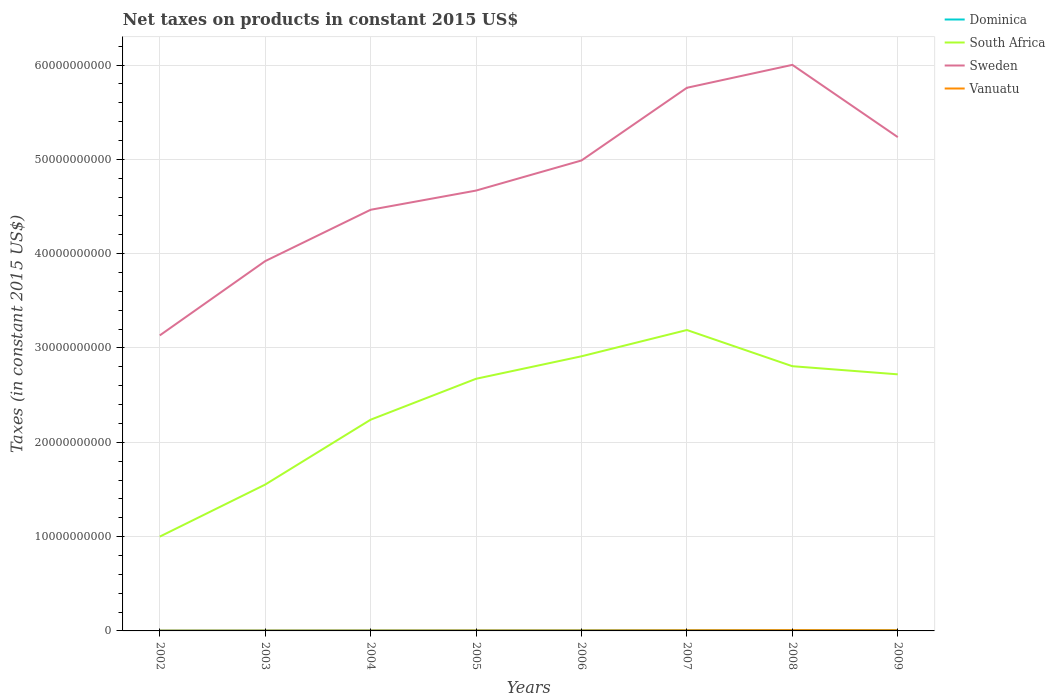How many different coloured lines are there?
Provide a short and direct response. 4. Is the number of lines equal to the number of legend labels?
Your response must be concise. Yes. Across all years, what is the maximum net taxes on products in South Africa?
Your response must be concise. 1.00e+1. What is the total net taxes on products in Vanuatu in the graph?
Offer a very short reply. -5.56e+06. What is the difference between the highest and the second highest net taxes on products in Dominica?
Offer a very short reply. 4.77e+07. How many years are there in the graph?
Provide a short and direct response. 8. What is the difference between two consecutive major ticks on the Y-axis?
Give a very brief answer. 1.00e+1. Are the values on the major ticks of Y-axis written in scientific E-notation?
Keep it short and to the point. No. Does the graph contain any zero values?
Offer a very short reply. No. Does the graph contain grids?
Provide a short and direct response. Yes. Where does the legend appear in the graph?
Keep it short and to the point. Top right. How many legend labels are there?
Provide a succinct answer. 4. How are the legend labels stacked?
Keep it short and to the point. Vertical. What is the title of the graph?
Ensure brevity in your answer.  Net taxes on products in constant 2015 US$. Does "United Kingdom" appear as one of the legend labels in the graph?
Ensure brevity in your answer.  No. What is the label or title of the X-axis?
Your answer should be very brief. Years. What is the label or title of the Y-axis?
Your answer should be compact. Taxes (in constant 2015 US$). What is the Taxes (in constant 2015 US$) in Dominica in 2002?
Keep it short and to the point. 3.84e+07. What is the Taxes (in constant 2015 US$) in South Africa in 2002?
Provide a succinct answer. 1.00e+1. What is the Taxes (in constant 2015 US$) in Sweden in 2002?
Give a very brief answer. 3.13e+1. What is the Taxes (in constant 2015 US$) in Vanuatu in 2002?
Give a very brief answer. 3.06e+07. What is the Taxes (in constant 2015 US$) in Dominica in 2003?
Keep it short and to the point. 4.41e+07. What is the Taxes (in constant 2015 US$) of South Africa in 2003?
Give a very brief answer. 1.55e+1. What is the Taxes (in constant 2015 US$) of Sweden in 2003?
Offer a very short reply. 3.92e+1. What is the Taxes (in constant 2015 US$) of Vanuatu in 2003?
Ensure brevity in your answer.  3.56e+07. What is the Taxes (in constant 2015 US$) of Dominica in 2004?
Your answer should be compact. 5.27e+07. What is the Taxes (in constant 2015 US$) in South Africa in 2004?
Your response must be concise. 2.24e+1. What is the Taxes (in constant 2015 US$) of Sweden in 2004?
Offer a very short reply. 4.47e+1. What is the Taxes (in constant 2015 US$) of Vanuatu in 2004?
Ensure brevity in your answer.  4.18e+07. What is the Taxes (in constant 2015 US$) in Dominica in 2005?
Offer a very short reply. 5.63e+07. What is the Taxes (in constant 2015 US$) in South Africa in 2005?
Provide a succinct answer. 2.67e+1. What is the Taxes (in constant 2015 US$) of Sweden in 2005?
Make the answer very short. 4.67e+1. What is the Taxes (in constant 2015 US$) of Vanuatu in 2005?
Offer a terse response. 4.74e+07. What is the Taxes (in constant 2015 US$) in Dominica in 2006?
Your answer should be very brief. 6.32e+07. What is the Taxes (in constant 2015 US$) in South Africa in 2006?
Your answer should be very brief. 2.91e+1. What is the Taxes (in constant 2015 US$) of Sweden in 2006?
Your answer should be very brief. 4.99e+1. What is the Taxes (in constant 2015 US$) of Vanuatu in 2006?
Keep it short and to the point. 5.19e+07. What is the Taxes (in constant 2015 US$) of Dominica in 2007?
Provide a succinct answer. 7.48e+07. What is the Taxes (in constant 2015 US$) of South Africa in 2007?
Your answer should be compact. 3.19e+1. What is the Taxes (in constant 2015 US$) in Sweden in 2007?
Provide a short and direct response. 5.76e+1. What is the Taxes (in constant 2015 US$) in Vanuatu in 2007?
Make the answer very short. 6.96e+07. What is the Taxes (in constant 2015 US$) of Dominica in 2008?
Provide a short and direct response. 8.21e+07. What is the Taxes (in constant 2015 US$) of South Africa in 2008?
Your response must be concise. 2.81e+1. What is the Taxes (in constant 2015 US$) in Sweden in 2008?
Keep it short and to the point. 6.00e+1. What is the Taxes (in constant 2015 US$) in Vanuatu in 2008?
Your answer should be very brief. 8.28e+07. What is the Taxes (in constant 2015 US$) in Dominica in 2009?
Give a very brief answer. 8.62e+07. What is the Taxes (in constant 2015 US$) of South Africa in 2009?
Your response must be concise. 2.72e+1. What is the Taxes (in constant 2015 US$) in Sweden in 2009?
Provide a succinct answer. 5.24e+1. What is the Taxes (in constant 2015 US$) of Vanuatu in 2009?
Provide a short and direct response. 7.68e+07. Across all years, what is the maximum Taxes (in constant 2015 US$) of Dominica?
Offer a terse response. 8.62e+07. Across all years, what is the maximum Taxes (in constant 2015 US$) in South Africa?
Provide a short and direct response. 3.19e+1. Across all years, what is the maximum Taxes (in constant 2015 US$) of Sweden?
Your answer should be compact. 6.00e+1. Across all years, what is the maximum Taxes (in constant 2015 US$) in Vanuatu?
Offer a terse response. 8.28e+07. Across all years, what is the minimum Taxes (in constant 2015 US$) in Dominica?
Offer a terse response. 3.84e+07. Across all years, what is the minimum Taxes (in constant 2015 US$) in South Africa?
Your answer should be very brief. 1.00e+1. Across all years, what is the minimum Taxes (in constant 2015 US$) of Sweden?
Ensure brevity in your answer.  3.13e+1. Across all years, what is the minimum Taxes (in constant 2015 US$) of Vanuatu?
Provide a short and direct response. 3.06e+07. What is the total Taxes (in constant 2015 US$) of Dominica in the graph?
Provide a succinct answer. 4.98e+08. What is the total Taxes (in constant 2015 US$) in South Africa in the graph?
Your answer should be very brief. 1.91e+11. What is the total Taxes (in constant 2015 US$) in Sweden in the graph?
Provide a short and direct response. 3.82e+11. What is the total Taxes (in constant 2015 US$) in Vanuatu in the graph?
Ensure brevity in your answer.  4.37e+08. What is the difference between the Taxes (in constant 2015 US$) in Dominica in 2002 and that in 2003?
Your response must be concise. -5.64e+06. What is the difference between the Taxes (in constant 2015 US$) of South Africa in 2002 and that in 2003?
Offer a very short reply. -5.52e+09. What is the difference between the Taxes (in constant 2015 US$) of Sweden in 2002 and that in 2003?
Your response must be concise. -7.88e+09. What is the difference between the Taxes (in constant 2015 US$) in Vanuatu in 2002 and that in 2003?
Offer a very short reply. -4.97e+06. What is the difference between the Taxes (in constant 2015 US$) in Dominica in 2002 and that in 2004?
Your answer should be very brief. -1.43e+07. What is the difference between the Taxes (in constant 2015 US$) of South Africa in 2002 and that in 2004?
Your answer should be compact. -1.24e+1. What is the difference between the Taxes (in constant 2015 US$) of Sweden in 2002 and that in 2004?
Keep it short and to the point. -1.33e+1. What is the difference between the Taxes (in constant 2015 US$) of Vanuatu in 2002 and that in 2004?
Keep it short and to the point. -1.12e+07. What is the difference between the Taxes (in constant 2015 US$) of Dominica in 2002 and that in 2005?
Ensure brevity in your answer.  -1.79e+07. What is the difference between the Taxes (in constant 2015 US$) in South Africa in 2002 and that in 2005?
Ensure brevity in your answer.  -1.67e+1. What is the difference between the Taxes (in constant 2015 US$) in Sweden in 2002 and that in 2005?
Ensure brevity in your answer.  -1.54e+1. What is the difference between the Taxes (in constant 2015 US$) of Vanuatu in 2002 and that in 2005?
Give a very brief answer. -1.68e+07. What is the difference between the Taxes (in constant 2015 US$) in Dominica in 2002 and that in 2006?
Provide a short and direct response. -2.48e+07. What is the difference between the Taxes (in constant 2015 US$) in South Africa in 2002 and that in 2006?
Ensure brevity in your answer.  -1.91e+1. What is the difference between the Taxes (in constant 2015 US$) in Sweden in 2002 and that in 2006?
Make the answer very short. -1.85e+1. What is the difference between the Taxes (in constant 2015 US$) of Vanuatu in 2002 and that in 2006?
Offer a very short reply. -2.13e+07. What is the difference between the Taxes (in constant 2015 US$) in Dominica in 2002 and that in 2007?
Ensure brevity in your answer.  -3.64e+07. What is the difference between the Taxes (in constant 2015 US$) in South Africa in 2002 and that in 2007?
Give a very brief answer. -2.19e+1. What is the difference between the Taxes (in constant 2015 US$) in Sweden in 2002 and that in 2007?
Offer a very short reply. -2.63e+1. What is the difference between the Taxes (in constant 2015 US$) of Vanuatu in 2002 and that in 2007?
Ensure brevity in your answer.  -3.90e+07. What is the difference between the Taxes (in constant 2015 US$) in Dominica in 2002 and that in 2008?
Keep it short and to the point. -4.36e+07. What is the difference between the Taxes (in constant 2015 US$) of South Africa in 2002 and that in 2008?
Ensure brevity in your answer.  -1.81e+1. What is the difference between the Taxes (in constant 2015 US$) in Sweden in 2002 and that in 2008?
Keep it short and to the point. -2.87e+1. What is the difference between the Taxes (in constant 2015 US$) of Vanuatu in 2002 and that in 2008?
Offer a terse response. -5.22e+07. What is the difference between the Taxes (in constant 2015 US$) of Dominica in 2002 and that in 2009?
Give a very brief answer. -4.77e+07. What is the difference between the Taxes (in constant 2015 US$) in South Africa in 2002 and that in 2009?
Make the answer very short. -1.72e+1. What is the difference between the Taxes (in constant 2015 US$) of Sweden in 2002 and that in 2009?
Keep it short and to the point. -2.10e+1. What is the difference between the Taxes (in constant 2015 US$) of Vanuatu in 2002 and that in 2009?
Make the answer very short. -4.61e+07. What is the difference between the Taxes (in constant 2015 US$) of Dominica in 2003 and that in 2004?
Offer a terse response. -8.61e+06. What is the difference between the Taxes (in constant 2015 US$) of South Africa in 2003 and that in 2004?
Provide a succinct answer. -6.88e+09. What is the difference between the Taxes (in constant 2015 US$) of Sweden in 2003 and that in 2004?
Your answer should be very brief. -5.44e+09. What is the difference between the Taxes (in constant 2015 US$) in Vanuatu in 2003 and that in 2004?
Keep it short and to the point. -6.23e+06. What is the difference between the Taxes (in constant 2015 US$) of Dominica in 2003 and that in 2005?
Your response must be concise. -1.22e+07. What is the difference between the Taxes (in constant 2015 US$) of South Africa in 2003 and that in 2005?
Give a very brief answer. -1.12e+1. What is the difference between the Taxes (in constant 2015 US$) in Sweden in 2003 and that in 2005?
Provide a succinct answer. -7.48e+09. What is the difference between the Taxes (in constant 2015 US$) in Vanuatu in 2003 and that in 2005?
Give a very brief answer. -1.18e+07. What is the difference between the Taxes (in constant 2015 US$) in Dominica in 2003 and that in 2006?
Ensure brevity in your answer.  -1.92e+07. What is the difference between the Taxes (in constant 2015 US$) in South Africa in 2003 and that in 2006?
Ensure brevity in your answer.  -1.36e+1. What is the difference between the Taxes (in constant 2015 US$) of Sweden in 2003 and that in 2006?
Provide a short and direct response. -1.07e+1. What is the difference between the Taxes (in constant 2015 US$) of Vanuatu in 2003 and that in 2006?
Ensure brevity in your answer.  -1.63e+07. What is the difference between the Taxes (in constant 2015 US$) of Dominica in 2003 and that in 2007?
Your answer should be very brief. -3.08e+07. What is the difference between the Taxes (in constant 2015 US$) of South Africa in 2003 and that in 2007?
Make the answer very short. -1.64e+1. What is the difference between the Taxes (in constant 2015 US$) in Sweden in 2003 and that in 2007?
Ensure brevity in your answer.  -1.84e+1. What is the difference between the Taxes (in constant 2015 US$) in Vanuatu in 2003 and that in 2007?
Ensure brevity in your answer.  -3.40e+07. What is the difference between the Taxes (in constant 2015 US$) of Dominica in 2003 and that in 2008?
Keep it short and to the point. -3.80e+07. What is the difference between the Taxes (in constant 2015 US$) in South Africa in 2003 and that in 2008?
Ensure brevity in your answer.  -1.25e+1. What is the difference between the Taxes (in constant 2015 US$) in Sweden in 2003 and that in 2008?
Provide a succinct answer. -2.08e+1. What is the difference between the Taxes (in constant 2015 US$) of Vanuatu in 2003 and that in 2008?
Give a very brief answer. -4.72e+07. What is the difference between the Taxes (in constant 2015 US$) of Dominica in 2003 and that in 2009?
Give a very brief answer. -4.21e+07. What is the difference between the Taxes (in constant 2015 US$) in South Africa in 2003 and that in 2009?
Offer a terse response. -1.17e+1. What is the difference between the Taxes (in constant 2015 US$) of Sweden in 2003 and that in 2009?
Give a very brief answer. -1.31e+1. What is the difference between the Taxes (in constant 2015 US$) in Vanuatu in 2003 and that in 2009?
Your answer should be compact. -4.12e+07. What is the difference between the Taxes (in constant 2015 US$) of Dominica in 2004 and that in 2005?
Provide a short and direct response. -3.61e+06. What is the difference between the Taxes (in constant 2015 US$) in South Africa in 2004 and that in 2005?
Your response must be concise. -4.34e+09. What is the difference between the Taxes (in constant 2015 US$) in Sweden in 2004 and that in 2005?
Ensure brevity in your answer.  -2.04e+09. What is the difference between the Taxes (in constant 2015 US$) in Vanuatu in 2004 and that in 2005?
Keep it short and to the point. -5.56e+06. What is the difference between the Taxes (in constant 2015 US$) of Dominica in 2004 and that in 2006?
Keep it short and to the point. -1.06e+07. What is the difference between the Taxes (in constant 2015 US$) of South Africa in 2004 and that in 2006?
Keep it short and to the point. -6.72e+09. What is the difference between the Taxes (in constant 2015 US$) of Sweden in 2004 and that in 2006?
Your answer should be very brief. -5.23e+09. What is the difference between the Taxes (in constant 2015 US$) in Vanuatu in 2004 and that in 2006?
Your answer should be very brief. -1.01e+07. What is the difference between the Taxes (in constant 2015 US$) in Dominica in 2004 and that in 2007?
Your response must be concise. -2.21e+07. What is the difference between the Taxes (in constant 2015 US$) in South Africa in 2004 and that in 2007?
Ensure brevity in your answer.  -9.51e+09. What is the difference between the Taxes (in constant 2015 US$) in Sweden in 2004 and that in 2007?
Your answer should be very brief. -1.29e+1. What is the difference between the Taxes (in constant 2015 US$) in Vanuatu in 2004 and that in 2007?
Make the answer very short. -2.78e+07. What is the difference between the Taxes (in constant 2015 US$) of Dominica in 2004 and that in 2008?
Offer a very short reply. -2.94e+07. What is the difference between the Taxes (in constant 2015 US$) in South Africa in 2004 and that in 2008?
Provide a short and direct response. -5.67e+09. What is the difference between the Taxes (in constant 2015 US$) of Sweden in 2004 and that in 2008?
Offer a very short reply. -1.54e+1. What is the difference between the Taxes (in constant 2015 US$) of Vanuatu in 2004 and that in 2008?
Provide a short and direct response. -4.10e+07. What is the difference between the Taxes (in constant 2015 US$) of Dominica in 2004 and that in 2009?
Your answer should be compact. -3.35e+07. What is the difference between the Taxes (in constant 2015 US$) in South Africa in 2004 and that in 2009?
Your answer should be compact. -4.81e+09. What is the difference between the Taxes (in constant 2015 US$) of Sweden in 2004 and that in 2009?
Provide a short and direct response. -7.70e+09. What is the difference between the Taxes (in constant 2015 US$) in Vanuatu in 2004 and that in 2009?
Provide a short and direct response. -3.49e+07. What is the difference between the Taxes (in constant 2015 US$) of Dominica in 2005 and that in 2006?
Give a very brief answer. -6.94e+06. What is the difference between the Taxes (in constant 2015 US$) of South Africa in 2005 and that in 2006?
Make the answer very short. -2.38e+09. What is the difference between the Taxes (in constant 2015 US$) in Sweden in 2005 and that in 2006?
Your answer should be compact. -3.19e+09. What is the difference between the Taxes (in constant 2015 US$) of Vanuatu in 2005 and that in 2006?
Provide a succinct answer. -4.52e+06. What is the difference between the Taxes (in constant 2015 US$) in Dominica in 2005 and that in 2007?
Give a very brief answer. -1.85e+07. What is the difference between the Taxes (in constant 2015 US$) in South Africa in 2005 and that in 2007?
Keep it short and to the point. -5.17e+09. What is the difference between the Taxes (in constant 2015 US$) in Sweden in 2005 and that in 2007?
Provide a short and direct response. -1.09e+1. What is the difference between the Taxes (in constant 2015 US$) in Vanuatu in 2005 and that in 2007?
Make the answer very short. -2.22e+07. What is the difference between the Taxes (in constant 2015 US$) in Dominica in 2005 and that in 2008?
Your answer should be compact. -2.58e+07. What is the difference between the Taxes (in constant 2015 US$) of South Africa in 2005 and that in 2008?
Make the answer very short. -1.33e+09. What is the difference between the Taxes (in constant 2015 US$) of Sweden in 2005 and that in 2008?
Offer a terse response. -1.33e+1. What is the difference between the Taxes (in constant 2015 US$) in Vanuatu in 2005 and that in 2008?
Offer a very short reply. -3.55e+07. What is the difference between the Taxes (in constant 2015 US$) in Dominica in 2005 and that in 2009?
Provide a short and direct response. -2.99e+07. What is the difference between the Taxes (in constant 2015 US$) in South Africa in 2005 and that in 2009?
Make the answer very short. -4.71e+08. What is the difference between the Taxes (in constant 2015 US$) of Sweden in 2005 and that in 2009?
Your answer should be compact. -5.67e+09. What is the difference between the Taxes (in constant 2015 US$) of Vanuatu in 2005 and that in 2009?
Your answer should be very brief. -2.94e+07. What is the difference between the Taxes (in constant 2015 US$) in Dominica in 2006 and that in 2007?
Make the answer very short. -1.16e+07. What is the difference between the Taxes (in constant 2015 US$) in South Africa in 2006 and that in 2007?
Make the answer very short. -2.79e+09. What is the difference between the Taxes (in constant 2015 US$) in Sweden in 2006 and that in 2007?
Your response must be concise. -7.71e+09. What is the difference between the Taxes (in constant 2015 US$) of Vanuatu in 2006 and that in 2007?
Ensure brevity in your answer.  -1.77e+07. What is the difference between the Taxes (in constant 2015 US$) of Dominica in 2006 and that in 2008?
Your response must be concise. -1.88e+07. What is the difference between the Taxes (in constant 2015 US$) in South Africa in 2006 and that in 2008?
Make the answer very short. 1.05e+09. What is the difference between the Taxes (in constant 2015 US$) in Sweden in 2006 and that in 2008?
Provide a succinct answer. -1.01e+1. What is the difference between the Taxes (in constant 2015 US$) in Vanuatu in 2006 and that in 2008?
Provide a succinct answer. -3.09e+07. What is the difference between the Taxes (in constant 2015 US$) of Dominica in 2006 and that in 2009?
Ensure brevity in your answer.  -2.29e+07. What is the difference between the Taxes (in constant 2015 US$) in South Africa in 2006 and that in 2009?
Provide a short and direct response. 1.91e+09. What is the difference between the Taxes (in constant 2015 US$) of Sweden in 2006 and that in 2009?
Keep it short and to the point. -2.47e+09. What is the difference between the Taxes (in constant 2015 US$) in Vanuatu in 2006 and that in 2009?
Your answer should be very brief. -2.49e+07. What is the difference between the Taxes (in constant 2015 US$) of Dominica in 2007 and that in 2008?
Keep it short and to the point. -7.23e+06. What is the difference between the Taxes (in constant 2015 US$) in South Africa in 2007 and that in 2008?
Your answer should be compact. 3.84e+09. What is the difference between the Taxes (in constant 2015 US$) in Sweden in 2007 and that in 2008?
Give a very brief answer. -2.43e+09. What is the difference between the Taxes (in constant 2015 US$) of Vanuatu in 2007 and that in 2008?
Offer a terse response. -1.32e+07. What is the difference between the Taxes (in constant 2015 US$) of Dominica in 2007 and that in 2009?
Your response must be concise. -1.13e+07. What is the difference between the Taxes (in constant 2015 US$) of South Africa in 2007 and that in 2009?
Ensure brevity in your answer.  4.70e+09. What is the difference between the Taxes (in constant 2015 US$) of Sweden in 2007 and that in 2009?
Provide a short and direct response. 5.23e+09. What is the difference between the Taxes (in constant 2015 US$) of Vanuatu in 2007 and that in 2009?
Offer a terse response. -7.15e+06. What is the difference between the Taxes (in constant 2015 US$) of Dominica in 2008 and that in 2009?
Keep it short and to the point. -4.10e+06. What is the difference between the Taxes (in constant 2015 US$) of South Africa in 2008 and that in 2009?
Provide a succinct answer. 8.62e+08. What is the difference between the Taxes (in constant 2015 US$) of Sweden in 2008 and that in 2009?
Make the answer very short. 7.66e+09. What is the difference between the Taxes (in constant 2015 US$) of Vanuatu in 2008 and that in 2009?
Provide a succinct answer. 6.08e+06. What is the difference between the Taxes (in constant 2015 US$) of Dominica in 2002 and the Taxes (in constant 2015 US$) of South Africa in 2003?
Your answer should be very brief. -1.55e+1. What is the difference between the Taxes (in constant 2015 US$) in Dominica in 2002 and the Taxes (in constant 2015 US$) in Sweden in 2003?
Your answer should be very brief. -3.92e+1. What is the difference between the Taxes (in constant 2015 US$) in Dominica in 2002 and the Taxes (in constant 2015 US$) in Vanuatu in 2003?
Give a very brief answer. 2.84e+06. What is the difference between the Taxes (in constant 2015 US$) in South Africa in 2002 and the Taxes (in constant 2015 US$) in Sweden in 2003?
Provide a short and direct response. -2.92e+1. What is the difference between the Taxes (in constant 2015 US$) of South Africa in 2002 and the Taxes (in constant 2015 US$) of Vanuatu in 2003?
Provide a short and direct response. 9.96e+09. What is the difference between the Taxes (in constant 2015 US$) of Sweden in 2002 and the Taxes (in constant 2015 US$) of Vanuatu in 2003?
Your response must be concise. 3.13e+1. What is the difference between the Taxes (in constant 2015 US$) in Dominica in 2002 and the Taxes (in constant 2015 US$) in South Africa in 2004?
Your answer should be very brief. -2.24e+1. What is the difference between the Taxes (in constant 2015 US$) of Dominica in 2002 and the Taxes (in constant 2015 US$) of Sweden in 2004?
Provide a short and direct response. -4.46e+1. What is the difference between the Taxes (in constant 2015 US$) of Dominica in 2002 and the Taxes (in constant 2015 US$) of Vanuatu in 2004?
Offer a very short reply. -3.39e+06. What is the difference between the Taxes (in constant 2015 US$) in South Africa in 2002 and the Taxes (in constant 2015 US$) in Sweden in 2004?
Provide a short and direct response. -3.47e+1. What is the difference between the Taxes (in constant 2015 US$) of South Africa in 2002 and the Taxes (in constant 2015 US$) of Vanuatu in 2004?
Your answer should be compact. 9.96e+09. What is the difference between the Taxes (in constant 2015 US$) of Sweden in 2002 and the Taxes (in constant 2015 US$) of Vanuatu in 2004?
Provide a succinct answer. 3.13e+1. What is the difference between the Taxes (in constant 2015 US$) in Dominica in 2002 and the Taxes (in constant 2015 US$) in South Africa in 2005?
Ensure brevity in your answer.  -2.67e+1. What is the difference between the Taxes (in constant 2015 US$) in Dominica in 2002 and the Taxes (in constant 2015 US$) in Sweden in 2005?
Your answer should be compact. -4.67e+1. What is the difference between the Taxes (in constant 2015 US$) of Dominica in 2002 and the Taxes (in constant 2015 US$) of Vanuatu in 2005?
Offer a terse response. -8.95e+06. What is the difference between the Taxes (in constant 2015 US$) of South Africa in 2002 and the Taxes (in constant 2015 US$) of Sweden in 2005?
Offer a terse response. -3.67e+1. What is the difference between the Taxes (in constant 2015 US$) of South Africa in 2002 and the Taxes (in constant 2015 US$) of Vanuatu in 2005?
Your response must be concise. 9.95e+09. What is the difference between the Taxes (in constant 2015 US$) of Sweden in 2002 and the Taxes (in constant 2015 US$) of Vanuatu in 2005?
Make the answer very short. 3.13e+1. What is the difference between the Taxes (in constant 2015 US$) of Dominica in 2002 and the Taxes (in constant 2015 US$) of South Africa in 2006?
Keep it short and to the point. -2.91e+1. What is the difference between the Taxes (in constant 2015 US$) of Dominica in 2002 and the Taxes (in constant 2015 US$) of Sweden in 2006?
Provide a short and direct response. -4.98e+1. What is the difference between the Taxes (in constant 2015 US$) in Dominica in 2002 and the Taxes (in constant 2015 US$) in Vanuatu in 2006?
Offer a very short reply. -1.35e+07. What is the difference between the Taxes (in constant 2015 US$) of South Africa in 2002 and the Taxes (in constant 2015 US$) of Sweden in 2006?
Give a very brief answer. -3.99e+1. What is the difference between the Taxes (in constant 2015 US$) of South Africa in 2002 and the Taxes (in constant 2015 US$) of Vanuatu in 2006?
Give a very brief answer. 9.95e+09. What is the difference between the Taxes (in constant 2015 US$) in Sweden in 2002 and the Taxes (in constant 2015 US$) in Vanuatu in 2006?
Provide a short and direct response. 3.13e+1. What is the difference between the Taxes (in constant 2015 US$) in Dominica in 2002 and the Taxes (in constant 2015 US$) in South Africa in 2007?
Your answer should be compact. -3.19e+1. What is the difference between the Taxes (in constant 2015 US$) of Dominica in 2002 and the Taxes (in constant 2015 US$) of Sweden in 2007?
Offer a very short reply. -5.76e+1. What is the difference between the Taxes (in constant 2015 US$) in Dominica in 2002 and the Taxes (in constant 2015 US$) in Vanuatu in 2007?
Make the answer very short. -3.12e+07. What is the difference between the Taxes (in constant 2015 US$) of South Africa in 2002 and the Taxes (in constant 2015 US$) of Sweden in 2007?
Your response must be concise. -4.76e+1. What is the difference between the Taxes (in constant 2015 US$) in South Africa in 2002 and the Taxes (in constant 2015 US$) in Vanuatu in 2007?
Keep it short and to the point. 9.93e+09. What is the difference between the Taxes (in constant 2015 US$) of Sweden in 2002 and the Taxes (in constant 2015 US$) of Vanuatu in 2007?
Your answer should be very brief. 3.13e+1. What is the difference between the Taxes (in constant 2015 US$) in Dominica in 2002 and the Taxes (in constant 2015 US$) in South Africa in 2008?
Your answer should be compact. -2.80e+1. What is the difference between the Taxes (in constant 2015 US$) in Dominica in 2002 and the Taxes (in constant 2015 US$) in Sweden in 2008?
Offer a very short reply. -6.00e+1. What is the difference between the Taxes (in constant 2015 US$) in Dominica in 2002 and the Taxes (in constant 2015 US$) in Vanuatu in 2008?
Make the answer very short. -4.44e+07. What is the difference between the Taxes (in constant 2015 US$) of South Africa in 2002 and the Taxes (in constant 2015 US$) of Sweden in 2008?
Give a very brief answer. -5.00e+1. What is the difference between the Taxes (in constant 2015 US$) of South Africa in 2002 and the Taxes (in constant 2015 US$) of Vanuatu in 2008?
Your answer should be very brief. 9.92e+09. What is the difference between the Taxes (in constant 2015 US$) in Sweden in 2002 and the Taxes (in constant 2015 US$) in Vanuatu in 2008?
Keep it short and to the point. 3.12e+1. What is the difference between the Taxes (in constant 2015 US$) in Dominica in 2002 and the Taxes (in constant 2015 US$) in South Africa in 2009?
Offer a very short reply. -2.72e+1. What is the difference between the Taxes (in constant 2015 US$) of Dominica in 2002 and the Taxes (in constant 2015 US$) of Sweden in 2009?
Your response must be concise. -5.23e+1. What is the difference between the Taxes (in constant 2015 US$) in Dominica in 2002 and the Taxes (in constant 2015 US$) in Vanuatu in 2009?
Ensure brevity in your answer.  -3.83e+07. What is the difference between the Taxes (in constant 2015 US$) of South Africa in 2002 and the Taxes (in constant 2015 US$) of Sweden in 2009?
Offer a terse response. -4.24e+1. What is the difference between the Taxes (in constant 2015 US$) of South Africa in 2002 and the Taxes (in constant 2015 US$) of Vanuatu in 2009?
Keep it short and to the point. 9.92e+09. What is the difference between the Taxes (in constant 2015 US$) of Sweden in 2002 and the Taxes (in constant 2015 US$) of Vanuatu in 2009?
Give a very brief answer. 3.13e+1. What is the difference between the Taxes (in constant 2015 US$) of Dominica in 2003 and the Taxes (in constant 2015 US$) of South Africa in 2004?
Offer a terse response. -2.24e+1. What is the difference between the Taxes (in constant 2015 US$) in Dominica in 2003 and the Taxes (in constant 2015 US$) in Sweden in 2004?
Give a very brief answer. -4.46e+1. What is the difference between the Taxes (in constant 2015 US$) of Dominica in 2003 and the Taxes (in constant 2015 US$) of Vanuatu in 2004?
Offer a terse response. 2.26e+06. What is the difference between the Taxes (in constant 2015 US$) of South Africa in 2003 and the Taxes (in constant 2015 US$) of Sweden in 2004?
Your answer should be compact. -2.91e+1. What is the difference between the Taxes (in constant 2015 US$) in South Africa in 2003 and the Taxes (in constant 2015 US$) in Vanuatu in 2004?
Your answer should be compact. 1.55e+1. What is the difference between the Taxes (in constant 2015 US$) of Sweden in 2003 and the Taxes (in constant 2015 US$) of Vanuatu in 2004?
Make the answer very short. 3.92e+1. What is the difference between the Taxes (in constant 2015 US$) of Dominica in 2003 and the Taxes (in constant 2015 US$) of South Africa in 2005?
Give a very brief answer. -2.67e+1. What is the difference between the Taxes (in constant 2015 US$) of Dominica in 2003 and the Taxes (in constant 2015 US$) of Sweden in 2005?
Your answer should be compact. -4.66e+1. What is the difference between the Taxes (in constant 2015 US$) of Dominica in 2003 and the Taxes (in constant 2015 US$) of Vanuatu in 2005?
Offer a terse response. -3.30e+06. What is the difference between the Taxes (in constant 2015 US$) in South Africa in 2003 and the Taxes (in constant 2015 US$) in Sweden in 2005?
Ensure brevity in your answer.  -3.12e+1. What is the difference between the Taxes (in constant 2015 US$) of South Africa in 2003 and the Taxes (in constant 2015 US$) of Vanuatu in 2005?
Provide a short and direct response. 1.55e+1. What is the difference between the Taxes (in constant 2015 US$) in Sweden in 2003 and the Taxes (in constant 2015 US$) in Vanuatu in 2005?
Give a very brief answer. 3.92e+1. What is the difference between the Taxes (in constant 2015 US$) in Dominica in 2003 and the Taxes (in constant 2015 US$) in South Africa in 2006?
Your answer should be very brief. -2.91e+1. What is the difference between the Taxes (in constant 2015 US$) in Dominica in 2003 and the Taxes (in constant 2015 US$) in Sweden in 2006?
Make the answer very short. -4.98e+1. What is the difference between the Taxes (in constant 2015 US$) of Dominica in 2003 and the Taxes (in constant 2015 US$) of Vanuatu in 2006?
Your answer should be very brief. -7.82e+06. What is the difference between the Taxes (in constant 2015 US$) in South Africa in 2003 and the Taxes (in constant 2015 US$) in Sweden in 2006?
Your response must be concise. -3.44e+1. What is the difference between the Taxes (in constant 2015 US$) of South Africa in 2003 and the Taxes (in constant 2015 US$) of Vanuatu in 2006?
Offer a very short reply. 1.55e+1. What is the difference between the Taxes (in constant 2015 US$) in Sweden in 2003 and the Taxes (in constant 2015 US$) in Vanuatu in 2006?
Give a very brief answer. 3.92e+1. What is the difference between the Taxes (in constant 2015 US$) in Dominica in 2003 and the Taxes (in constant 2015 US$) in South Africa in 2007?
Ensure brevity in your answer.  -3.19e+1. What is the difference between the Taxes (in constant 2015 US$) of Dominica in 2003 and the Taxes (in constant 2015 US$) of Sweden in 2007?
Your answer should be compact. -5.75e+1. What is the difference between the Taxes (in constant 2015 US$) in Dominica in 2003 and the Taxes (in constant 2015 US$) in Vanuatu in 2007?
Offer a terse response. -2.55e+07. What is the difference between the Taxes (in constant 2015 US$) in South Africa in 2003 and the Taxes (in constant 2015 US$) in Sweden in 2007?
Provide a succinct answer. -4.21e+1. What is the difference between the Taxes (in constant 2015 US$) of South Africa in 2003 and the Taxes (in constant 2015 US$) of Vanuatu in 2007?
Offer a terse response. 1.54e+1. What is the difference between the Taxes (in constant 2015 US$) of Sweden in 2003 and the Taxes (in constant 2015 US$) of Vanuatu in 2007?
Your answer should be very brief. 3.91e+1. What is the difference between the Taxes (in constant 2015 US$) in Dominica in 2003 and the Taxes (in constant 2015 US$) in South Africa in 2008?
Keep it short and to the point. -2.80e+1. What is the difference between the Taxes (in constant 2015 US$) of Dominica in 2003 and the Taxes (in constant 2015 US$) of Sweden in 2008?
Your response must be concise. -6.00e+1. What is the difference between the Taxes (in constant 2015 US$) in Dominica in 2003 and the Taxes (in constant 2015 US$) in Vanuatu in 2008?
Offer a very short reply. -3.88e+07. What is the difference between the Taxes (in constant 2015 US$) in South Africa in 2003 and the Taxes (in constant 2015 US$) in Sweden in 2008?
Your response must be concise. -4.45e+1. What is the difference between the Taxes (in constant 2015 US$) of South Africa in 2003 and the Taxes (in constant 2015 US$) of Vanuatu in 2008?
Provide a succinct answer. 1.54e+1. What is the difference between the Taxes (in constant 2015 US$) of Sweden in 2003 and the Taxes (in constant 2015 US$) of Vanuatu in 2008?
Make the answer very short. 3.91e+1. What is the difference between the Taxes (in constant 2015 US$) of Dominica in 2003 and the Taxes (in constant 2015 US$) of South Africa in 2009?
Make the answer very short. -2.72e+1. What is the difference between the Taxes (in constant 2015 US$) of Dominica in 2003 and the Taxes (in constant 2015 US$) of Sweden in 2009?
Keep it short and to the point. -5.23e+1. What is the difference between the Taxes (in constant 2015 US$) of Dominica in 2003 and the Taxes (in constant 2015 US$) of Vanuatu in 2009?
Your response must be concise. -3.27e+07. What is the difference between the Taxes (in constant 2015 US$) of South Africa in 2003 and the Taxes (in constant 2015 US$) of Sweden in 2009?
Your answer should be compact. -3.68e+1. What is the difference between the Taxes (in constant 2015 US$) of South Africa in 2003 and the Taxes (in constant 2015 US$) of Vanuatu in 2009?
Ensure brevity in your answer.  1.54e+1. What is the difference between the Taxes (in constant 2015 US$) in Sweden in 2003 and the Taxes (in constant 2015 US$) in Vanuatu in 2009?
Your response must be concise. 3.91e+1. What is the difference between the Taxes (in constant 2015 US$) in Dominica in 2004 and the Taxes (in constant 2015 US$) in South Africa in 2005?
Give a very brief answer. -2.67e+1. What is the difference between the Taxes (in constant 2015 US$) of Dominica in 2004 and the Taxes (in constant 2015 US$) of Sweden in 2005?
Ensure brevity in your answer.  -4.66e+1. What is the difference between the Taxes (in constant 2015 US$) in Dominica in 2004 and the Taxes (in constant 2015 US$) in Vanuatu in 2005?
Give a very brief answer. 5.31e+06. What is the difference between the Taxes (in constant 2015 US$) of South Africa in 2004 and the Taxes (in constant 2015 US$) of Sweden in 2005?
Make the answer very short. -2.43e+1. What is the difference between the Taxes (in constant 2015 US$) of South Africa in 2004 and the Taxes (in constant 2015 US$) of Vanuatu in 2005?
Give a very brief answer. 2.23e+1. What is the difference between the Taxes (in constant 2015 US$) in Sweden in 2004 and the Taxes (in constant 2015 US$) in Vanuatu in 2005?
Your answer should be very brief. 4.46e+1. What is the difference between the Taxes (in constant 2015 US$) of Dominica in 2004 and the Taxes (in constant 2015 US$) of South Africa in 2006?
Make the answer very short. -2.91e+1. What is the difference between the Taxes (in constant 2015 US$) of Dominica in 2004 and the Taxes (in constant 2015 US$) of Sweden in 2006?
Ensure brevity in your answer.  -4.98e+1. What is the difference between the Taxes (in constant 2015 US$) in Dominica in 2004 and the Taxes (in constant 2015 US$) in Vanuatu in 2006?
Make the answer very short. 7.89e+05. What is the difference between the Taxes (in constant 2015 US$) of South Africa in 2004 and the Taxes (in constant 2015 US$) of Sweden in 2006?
Give a very brief answer. -2.75e+1. What is the difference between the Taxes (in constant 2015 US$) in South Africa in 2004 and the Taxes (in constant 2015 US$) in Vanuatu in 2006?
Keep it short and to the point. 2.23e+1. What is the difference between the Taxes (in constant 2015 US$) in Sweden in 2004 and the Taxes (in constant 2015 US$) in Vanuatu in 2006?
Offer a very short reply. 4.46e+1. What is the difference between the Taxes (in constant 2015 US$) of Dominica in 2004 and the Taxes (in constant 2015 US$) of South Africa in 2007?
Provide a succinct answer. -3.19e+1. What is the difference between the Taxes (in constant 2015 US$) of Dominica in 2004 and the Taxes (in constant 2015 US$) of Sweden in 2007?
Your answer should be compact. -5.75e+1. What is the difference between the Taxes (in constant 2015 US$) of Dominica in 2004 and the Taxes (in constant 2015 US$) of Vanuatu in 2007?
Give a very brief answer. -1.69e+07. What is the difference between the Taxes (in constant 2015 US$) in South Africa in 2004 and the Taxes (in constant 2015 US$) in Sweden in 2007?
Give a very brief answer. -3.52e+1. What is the difference between the Taxes (in constant 2015 US$) of South Africa in 2004 and the Taxes (in constant 2015 US$) of Vanuatu in 2007?
Give a very brief answer. 2.23e+1. What is the difference between the Taxes (in constant 2015 US$) in Sweden in 2004 and the Taxes (in constant 2015 US$) in Vanuatu in 2007?
Your response must be concise. 4.46e+1. What is the difference between the Taxes (in constant 2015 US$) of Dominica in 2004 and the Taxes (in constant 2015 US$) of South Africa in 2008?
Provide a short and direct response. -2.80e+1. What is the difference between the Taxes (in constant 2015 US$) of Dominica in 2004 and the Taxes (in constant 2015 US$) of Sweden in 2008?
Your answer should be compact. -6.00e+1. What is the difference between the Taxes (in constant 2015 US$) of Dominica in 2004 and the Taxes (in constant 2015 US$) of Vanuatu in 2008?
Ensure brevity in your answer.  -3.01e+07. What is the difference between the Taxes (in constant 2015 US$) of South Africa in 2004 and the Taxes (in constant 2015 US$) of Sweden in 2008?
Your answer should be compact. -3.76e+1. What is the difference between the Taxes (in constant 2015 US$) of South Africa in 2004 and the Taxes (in constant 2015 US$) of Vanuatu in 2008?
Your response must be concise. 2.23e+1. What is the difference between the Taxes (in constant 2015 US$) of Sweden in 2004 and the Taxes (in constant 2015 US$) of Vanuatu in 2008?
Your answer should be compact. 4.46e+1. What is the difference between the Taxes (in constant 2015 US$) in Dominica in 2004 and the Taxes (in constant 2015 US$) in South Africa in 2009?
Keep it short and to the point. -2.72e+1. What is the difference between the Taxes (in constant 2015 US$) of Dominica in 2004 and the Taxes (in constant 2015 US$) of Sweden in 2009?
Provide a short and direct response. -5.23e+1. What is the difference between the Taxes (in constant 2015 US$) in Dominica in 2004 and the Taxes (in constant 2015 US$) in Vanuatu in 2009?
Give a very brief answer. -2.41e+07. What is the difference between the Taxes (in constant 2015 US$) of South Africa in 2004 and the Taxes (in constant 2015 US$) of Sweden in 2009?
Your answer should be very brief. -3.00e+1. What is the difference between the Taxes (in constant 2015 US$) of South Africa in 2004 and the Taxes (in constant 2015 US$) of Vanuatu in 2009?
Offer a terse response. 2.23e+1. What is the difference between the Taxes (in constant 2015 US$) in Sweden in 2004 and the Taxes (in constant 2015 US$) in Vanuatu in 2009?
Your response must be concise. 4.46e+1. What is the difference between the Taxes (in constant 2015 US$) in Dominica in 2005 and the Taxes (in constant 2015 US$) in South Africa in 2006?
Keep it short and to the point. -2.91e+1. What is the difference between the Taxes (in constant 2015 US$) in Dominica in 2005 and the Taxes (in constant 2015 US$) in Sweden in 2006?
Provide a succinct answer. -4.98e+1. What is the difference between the Taxes (in constant 2015 US$) of Dominica in 2005 and the Taxes (in constant 2015 US$) of Vanuatu in 2006?
Offer a terse response. 4.40e+06. What is the difference between the Taxes (in constant 2015 US$) of South Africa in 2005 and the Taxes (in constant 2015 US$) of Sweden in 2006?
Offer a terse response. -2.31e+1. What is the difference between the Taxes (in constant 2015 US$) in South Africa in 2005 and the Taxes (in constant 2015 US$) in Vanuatu in 2006?
Offer a very short reply. 2.67e+1. What is the difference between the Taxes (in constant 2015 US$) in Sweden in 2005 and the Taxes (in constant 2015 US$) in Vanuatu in 2006?
Provide a short and direct response. 4.66e+1. What is the difference between the Taxes (in constant 2015 US$) of Dominica in 2005 and the Taxes (in constant 2015 US$) of South Africa in 2007?
Provide a succinct answer. -3.18e+1. What is the difference between the Taxes (in constant 2015 US$) in Dominica in 2005 and the Taxes (in constant 2015 US$) in Sweden in 2007?
Your answer should be very brief. -5.75e+1. What is the difference between the Taxes (in constant 2015 US$) in Dominica in 2005 and the Taxes (in constant 2015 US$) in Vanuatu in 2007?
Offer a very short reply. -1.33e+07. What is the difference between the Taxes (in constant 2015 US$) of South Africa in 2005 and the Taxes (in constant 2015 US$) of Sweden in 2007?
Provide a succinct answer. -3.09e+1. What is the difference between the Taxes (in constant 2015 US$) in South Africa in 2005 and the Taxes (in constant 2015 US$) in Vanuatu in 2007?
Offer a terse response. 2.67e+1. What is the difference between the Taxes (in constant 2015 US$) of Sweden in 2005 and the Taxes (in constant 2015 US$) of Vanuatu in 2007?
Make the answer very short. 4.66e+1. What is the difference between the Taxes (in constant 2015 US$) in Dominica in 2005 and the Taxes (in constant 2015 US$) in South Africa in 2008?
Make the answer very short. -2.80e+1. What is the difference between the Taxes (in constant 2015 US$) in Dominica in 2005 and the Taxes (in constant 2015 US$) in Sweden in 2008?
Provide a short and direct response. -6.00e+1. What is the difference between the Taxes (in constant 2015 US$) of Dominica in 2005 and the Taxes (in constant 2015 US$) of Vanuatu in 2008?
Your answer should be compact. -2.65e+07. What is the difference between the Taxes (in constant 2015 US$) in South Africa in 2005 and the Taxes (in constant 2015 US$) in Sweden in 2008?
Offer a very short reply. -3.33e+1. What is the difference between the Taxes (in constant 2015 US$) of South Africa in 2005 and the Taxes (in constant 2015 US$) of Vanuatu in 2008?
Your response must be concise. 2.67e+1. What is the difference between the Taxes (in constant 2015 US$) in Sweden in 2005 and the Taxes (in constant 2015 US$) in Vanuatu in 2008?
Provide a succinct answer. 4.66e+1. What is the difference between the Taxes (in constant 2015 US$) in Dominica in 2005 and the Taxes (in constant 2015 US$) in South Africa in 2009?
Your answer should be very brief. -2.71e+1. What is the difference between the Taxes (in constant 2015 US$) in Dominica in 2005 and the Taxes (in constant 2015 US$) in Sweden in 2009?
Your response must be concise. -5.23e+1. What is the difference between the Taxes (in constant 2015 US$) of Dominica in 2005 and the Taxes (in constant 2015 US$) of Vanuatu in 2009?
Your answer should be compact. -2.05e+07. What is the difference between the Taxes (in constant 2015 US$) in South Africa in 2005 and the Taxes (in constant 2015 US$) in Sweden in 2009?
Provide a succinct answer. -2.56e+1. What is the difference between the Taxes (in constant 2015 US$) of South Africa in 2005 and the Taxes (in constant 2015 US$) of Vanuatu in 2009?
Your answer should be very brief. 2.67e+1. What is the difference between the Taxes (in constant 2015 US$) in Sweden in 2005 and the Taxes (in constant 2015 US$) in Vanuatu in 2009?
Make the answer very short. 4.66e+1. What is the difference between the Taxes (in constant 2015 US$) of Dominica in 2006 and the Taxes (in constant 2015 US$) of South Africa in 2007?
Your answer should be very brief. -3.18e+1. What is the difference between the Taxes (in constant 2015 US$) of Dominica in 2006 and the Taxes (in constant 2015 US$) of Sweden in 2007?
Your answer should be compact. -5.75e+1. What is the difference between the Taxes (in constant 2015 US$) of Dominica in 2006 and the Taxes (in constant 2015 US$) of Vanuatu in 2007?
Give a very brief answer. -6.36e+06. What is the difference between the Taxes (in constant 2015 US$) of South Africa in 2006 and the Taxes (in constant 2015 US$) of Sweden in 2007?
Make the answer very short. -2.85e+1. What is the difference between the Taxes (in constant 2015 US$) of South Africa in 2006 and the Taxes (in constant 2015 US$) of Vanuatu in 2007?
Ensure brevity in your answer.  2.90e+1. What is the difference between the Taxes (in constant 2015 US$) in Sweden in 2006 and the Taxes (in constant 2015 US$) in Vanuatu in 2007?
Ensure brevity in your answer.  4.98e+1. What is the difference between the Taxes (in constant 2015 US$) of Dominica in 2006 and the Taxes (in constant 2015 US$) of South Africa in 2008?
Your answer should be very brief. -2.80e+1. What is the difference between the Taxes (in constant 2015 US$) of Dominica in 2006 and the Taxes (in constant 2015 US$) of Sweden in 2008?
Provide a short and direct response. -6.00e+1. What is the difference between the Taxes (in constant 2015 US$) in Dominica in 2006 and the Taxes (in constant 2015 US$) in Vanuatu in 2008?
Ensure brevity in your answer.  -1.96e+07. What is the difference between the Taxes (in constant 2015 US$) in South Africa in 2006 and the Taxes (in constant 2015 US$) in Sweden in 2008?
Provide a succinct answer. -3.09e+1. What is the difference between the Taxes (in constant 2015 US$) in South Africa in 2006 and the Taxes (in constant 2015 US$) in Vanuatu in 2008?
Offer a very short reply. 2.90e+1. What is the difference between the Taxes (in constant 2015 US$) in Sweden in 2006 and the Taxes (in constant 2015 US$) in Vanuatu in 2008?
Provide a succinct answer. 4.98e+1. What is the difference between the Taxes (in constant 2015 US$) of Dominica in 2006 and the Taxes (in constant 2015 US$) of South Africa in 2009?
Your response must be concise. -2.71e+1. What is the difference between the Taxes (in constant 2015 US$) of Dominica in 2006 and the Taxes (in constant 2015 US$) of Sweden in 2009?
Your response must be concise. -5.23e+1. What is the difference between the Taxes (in constant 2015 US$) of Dominica in 2006 and the Taxes (in constant 2015 US$) of Vanuatu in 2009?
Your response must be concise. -1.35e+07. What is the difference between the Taxes (in constant 2015 US$) in South Africa in 2006 and the Taxes (in constant 2015 US$) in Sweden in 2009?
Provide a succinct answer. -2.32e+1. What is the difference between the Taxes (in constant 2015 US$) of South Africa in 2006 and the Taxes (in constant 2015 US$) of Vanuatu in 2009?
Make the answer very short. 2.90e+1. What is the difference between the Taxes (in constant 2015 US$) in Sweden in 2006 and the Taxes (in constant 2015 US$) in Vanuatu in 2009?
Give a very brief answer. 4.98e+1. What is the difference between the Taxes (in constant 2015 US$) of Dominica in 2007 and the Taxes (in constant 2015 US$) of South Africa in 2008?
Give a very brief answer. -2.80e+1. What is the difference between the Taxes (in constant 2015 US$) in Dominica in 2007 and the Taxes (in constant 2015 US$) in Sweden in 2008?
Your answer should be compact. -5.99e+1. What is the difference between the Taxes (in constant 2015 US$) of Dominica in 2007 and the Taxes (in constant 2015 US$) of Vanuatu in 2008?
Keep it short and to the point. -8.01e+06. What is the difference between the Taxes (in constant 2015 US$) in South Africa in 2007 and the Taxes (in constant 2015 US$) in Sweden in 2008?
Make the answer very short. -2.81e+1. What is the difference between the Taxes (in constant 2015 US$) of South Africa in 2007 and the Taxes (in constant 2015 US$) of Vanuatu in 2008?
Offer a terse response. 3.18e+1. What is the difference between the Taxes (in constant 2015 US$) in Sweden in 2007 and the Taxes (in constant 2015 US$) in Vanuatu in 2008?
Give a very brief answer. 5.75e+1. What is the difference between the Taxes (in constant 2015 US$) in Dominica in 2007 and the Taxes (in constant 2015 US$) in South Africa in 2009?
Provide a succinct answer. -2.71e+1. What is the difference between the Taxes (in constant 2015 US$) in Dominica in 2007 and the Taxes (in constant 2015 US$) in Sweden in 2009?
Provide a short and direct response. -5.23e+1. What is the difference between the Taxes (in constant 2015 US$) of Dominica in 2007 and the Taxes (in constant 2015 US$) of Vanuatu in 2009?
Offer a very short reply. -1.93e+06. What is the difference between the Taxes (in constant 2015 US$) in South Africa in 2007 and the Taxes (in constant 2015 US$) in Sweden in 2009?
Give a very brief answer. -2.05e+1. What is the difference between the Taxes (in constant 2015 US$) in South Africa in 2007 and the Taxes (in constant 2015 US$) in Vanuatu in 2009?
Your answer should be very brief. 3.18e+1. What is the difference between the Taxes (in constant 2015 US$) in Sweden in 2007 and the Taxes (in constant 2015 US$) in Vanuatu in 2009?
Your answer should be very brief. 5.75e+1. What is the difference between the Taxes (in constant 2015 US$) of Dominica in 2008 and the Taxes (in constant 2015 US$) of South Africa in 2009?
Offer a very short reply. -2.71e+1. What is the difference between the Taxes (in constant 2015 US$) of Dominica in 2008 and the Taxes (in constant 2015 US$) of Sweden in 2009?
Make the answer very short. -5.23e+1. What is the difference between the Taxes (in constant 2015 US$) of Dominica in 2008 and the Taxes (in constant 2015 US$) of Vanuatu in 2009?
Offer a very short reply. 5.30e+06. What is the difference between the Taxes (in constant 2015 US$) in South Africa in 2008 and the Taxes (in constant 2015 US$) in Sweden in 2009?
Your response must be concise. -2.43e+1. What is the difference between the Taxes (in constant 2015 US$) in South Africa in 2008 and the Taxes (in constant 2015 US$) in Vanuatu in 2009?
Keep it short and to the point. 2.80e+1. What is the difference between the Taxes (in constant 2015 US$) of Sweden in 2008 and the Taxes (in constant 2015 US$) of Vanuatu in 2009?
Your answer should be very brief. 5.99e+1. What is the average Taxes (in constant 2015 US$) in Dominica per year?
Your response must be concise. 6.22e+07. What is the average Taxes (in constant 2015 US$) in South Africa per year?
Ensure brevity in your answer.  2.39e+1. What is the average Taxes (in constant 2015 US$) of Sweden per year?
Provide a succinct answer. 4.77e+1. What is the average Taxes (in constant 2015 US$) of Vanuatu per year?
Give a very brief answer. 5.46e+07. In the year 2002, what is the difference between the Taxes (in constant 2015 US$) in Dominica and Taxes (in constant 2015 US$) in South Africa?
Keep it short and to the point. -9.96e+09. In the year 2002, what is the difference between the Taxes (in constant 2015 US$) in Dominica and Taxes (in constant 2015 US$) in Sweden?
Give a very brief answer. -3.13e+1. In the year 2002, what is the difference between the Taxes (in constant 2015 US$) of Dominica and Taxes (in constant 2015 US$) of Vanuatu?
Ensure brevity in your answer.  7.81e+06. In the year 2002, what is the difference between the Taxes (in constant 2015 US$) of South Africa and Taxes (in constant 2015 US$) of Sweden?
Ensure brevity in your answer.  -2.13e+1. In the year 2002, what is the difference between the Taxes (in constant 2015 US$) of South Africa and Taxes (in constant 2015 US$) of Vanuatu?
Give a very brief answer. 9.97e+09. In the year 2002, what is the difference between the Taxes (in constant 2015 US$) in Sweden and Taxes (in constant 2015 US$) in Vanuatu?
Ensure brevity in your answer.  3.13e+1. In the year 2003, what is the difference between the Taxes (in constant 2015 US$) in Dominica and Taxes (in constant 2015 US$) in South Africa?
Give a very brief answer. -1.55e+1. In the year 2003, what is the difference between the Taxes (in constant 2015 US$) of Dominica and Taxes (in constant 2015 US$) of Sweden?
Your answer should be very brief. -3.92e+1. In the year 2003, what is the difference between the Taxes (in constant 2015 US$) of Dominica and Taxes (in constant 2015 US$) of Vanuatu?
Your response must be concise. 8.48e+06. In the year 2003, what is the difference between the Taxes (in constant 2015 US$) in South Africa and Taxes (in constant 2015 US$) in Sweden?
Make the answer very short. -2.37e+1. In the year 2003, what is the difference between the Taxes (in constant 2015 US$) in South Africa and Taxes (in constant 2015 US$) in Vanuatu?
Your response must be concise. 1.55e+1. In the year 2003, what is the difference between the Taxes (in constant 2015 US$) of Sweden and Taxes (in constant 2015 US$) of Vanuatu?
Make the answer very short. 3.92e+1. In the year 2004, what is the difference between the Taxes (in constant 2015 US$) in Dominica and Taxes (in constant 2015 US$) in South Africa?
Ensure brevity in your answer.  -2.23e+1. In the year 2004, what is the difference between the Taxes (in constant 2015 US$) of Dominica and Taxes (in constant 2015 US$) of Sweden?
Offer a very short reply. -4.46e+1. In the year 2004, what is the difference between the Taxes (in constant 2015 US$) in Dominica and Taxes (in constant 2015 US$) in Vanuatu?
Provide a succinct answer. 1.09e+07. In the year 2004, what is the difference between the Taxes (in constant 2015 US$) in South Africa and Taxes (in constant 2015 US$) in Sweden?
Keep it short and to the point. -2.23e+1. In the year 2004, what is the difference between the Taxes (in constant 2015 US$) in South Africa and Taxes (in constant 2015 US$) in Vanuatu?
Your answer should be very brief. 2.24e+1. In the year 2004, what is the difference between the Taxes (in constant 2015 US$) in Sweden and Taxes (in constant 2015 US$) in Vanuatu?
Your answer should be compact. 4.46e+1. In the year 2005, what is the difference between the Taxes (in constant 2015 US$) of Dominica and Taxes (in constant 2015 US$) of South Africa?
Offer a very short reply. -2.67e+1. In the year 2005, what is the difference between the Taxes (in constant 2015 US$) in Dominica and Taxes (in constant 2015 US$) in Sweden?
Provide a succinct answer. -4.66e+1. In the year 2005, what is the difference between the Taxes (in constant 2015 US$) of Dominica and Taxes (in constant 2015 US$) of Vanuatu?
Your answer should be very brief. 8.92e+06. In the year 2005, what is the difference between the Taxes (in constant 2015 US$) of South Africa and Taxes (in constant 2015 US$) of Sweden?
Your answer should be compact. -2.00e+1. In the year 2005, what is the difference between the Taxes (in constant 2015 US$) of South Africa and Taxes (in constant 2015 US$) of Vanuatu?
Give a very brief answer. 2.67e+1. In the year 2005, what is the difference between the Taxes (in constant 2015 US$) of Sweden and Taxes (in constant 2015 US$) of Vanuatu?
Your response must be concise. 4.66e+1. In the year 2006, what is the difference between the Taxes (in constant 2015 US$) of Dominica and Taxes (in constant 2015 US$) of South Africa?
Your response must be concise. -2.91e+1. In the year 2006, what is the difference between the Taxes (in constant 2015 US$) in Dominica and Taxes (in constant 2015 US$) in Sweden?
Your answer should be very brief. -4.98e+1. In the year 2006, what is the difference between the Taxes (in constant 2015 US$) in Dominica and Taxes (in constant 2015 US$) in Vanuatu?
Offer a very short reply. 1.13e+07. In the year 2006, what is the difference between the Taxes (in constant 2015 US$) of South Africa and Taxes (in constant 2015 US$) of Sweden?
Give a very brief answer. -2.08e+1. In the year 2006, what is the difference between the Taxes (in constant 2015 US$) of South Africa and Taxes (in constant 2015 US$) of Vanuatu?
Make the answer very short. 2.91e+1. In the year 2006, what is the difference between the Taxes (in constant 2015 US$) of Sweden and Taxes (in constant 2015 US$) of Vanuatu?
Offer a very short reply. 4.98e+1. In the year 2007, what is the difference between the Taxes (in constant 2015 US$) of Dominica and Taxes (in constant 2015 US$) of South Africa?
Your response must be concise. -3.18e+1. In the year 2007, what is the difference between the Taxes (in constant 2015 US$) of Dominica and Taxes (in constant 2015 US$) of Sweden?
Provide a short and direct response. -5.75e+1. In the year 2007, what is the difference between the Taxes (in constant 2015 US$) in Dominica and Taxes (in constant 2015 US$) in Vanuatu?
Your response must be concise. 5.22e+06. In the year 2007, what is the difference between the Taxes (in constant 2015 US$) in South Africa and Taxes (in constant 2015 US$) in Sweden?
Provide a succinct answer. -2.57e+1. In the year 2007, what is the difference between the Taxes (in constant 2015 US$) of South Africa and Taxes (in constant 2015 US$) of Vanuatu?
Make the answer very short. 3.18e+1. In the year 2007, what is the difference between the Taxes (in constant 2015 US$) in Sweden and Taxes (in constant 2015 US$) in Vanuatu?
Make the answer very short. 5.75e+1. In the year 2008, what is the difference between the Taxes (in constant 2015 US$) in Dominica and Taxes (in constant 2015 US$) in South Africa?
Your answer should be very brief. -2.80e+1. In the year 2008, what is the difference between the Taxes (in constant 2015 US$) in Dominica and Taxes (in constant 2015 US$) in Sweden?
Provide a short and direct response. -5.99e+1. In the year 2008, what is the difference between the Taxes (in constant 2015 US$) of Dominica and Taxes (in constant 2015 US$) of Vanuatu?
Offer a terse response. -7.76e+05. In the year 2008, what is the difference between the Taxes (in constant 2015 US$) in South Africa and Taxes (in constant 2015 US$) in Sweden?
Provide a succinct answer. -3.20e+1. In the year 2008, what is the difference between the Taxes (in constant 2015 US$) of South Africa and Taxes (in constant 2015 US$) of Vanuatu?
Your answer should be very brief. 2.80e+1. In the year 2008, what is the difference between the Taxes (in constant 2015 US$) of Sweden and Taxes (in constant 2015 US$) of Vanuatu?
Your answer should be compact. 5.99e+1. In the year 2009, what is the difference between the Taxes (in constant 2015 US$) in Dominica and Taxes (in constant 2015 US$) in South Africa?
Give a very brief answer. -2.71e+1. In the year 2009, what is the difference between the Taxes (in constant 2015 US$) in Dominica and Taxes (in constant 2015 US$) in Sweden?
Your answer should be very brief. -5.23e+1. In the year 2009, what is the difference between the Taxes (in constant 2015 US$) in Dominica and Taxes (in constant 2015 US$) in Vanuatu?
Give a very brief answer. 9.40e+06. In the year 2009, what is the difference between the Taxes (in constant 2015 US$) in South Africa and Taxes (in constant 2015 US$) in Sweden?
Provide a short and direct response. -2.52e+1. In the year 2009, what is the difference between the Taxes (in constant 2015 US$) of South Africa and Taxes (in constant 2015 US$) of Vanuatu?
Give a very brief answer. 2.71e+1. In the year 2009, what is the difference between the Taxes (in constant 2015 US$) in Sweden and Taxes (in constant 2015 US$) in Vanuatu?
Your response must be concise. 5.23e+1. What is the ratio of the Taxes (in constant 2015 US$) in Dominica in 2002 to that in 2003?
Your answer should be compact. 0.87. What is the ratio of the Taxes (in constant 2015 US$) in South Africa in 2002 to that in 2003?
Give a very brief answer. 0.64. What is the ratio of the Taxes (in constant 2015 US$) in Sweden in 2002 to that in 2003?
Make the answer very short. 0.8. What is the ratio of the Taxes (in constant 2015 US$) in Vanuatu in 2002 to that in 2003?
Offer a very short reply. 0.86. What is the ratio of the Taxes (in constant 2015 US$) in Dominica in 2002 to that in 2004?
Ensure brevity in your answer.  0.73. What is the ratio of the Taxes (in constant 2015 US$) of South Africa in 2002 to that in 2004?
Provide a succinct answer. 0.45. What is the ratio of the Taxes (in constant 2015 US$) of Sweden in 2002 to that in 2004?
Offer a very short reply. 0.7. What is the ratio of the Taxes (in constant 2015 US$) in Vanuatu in 2002 to that in 2004?
Your response must be concise. 0.73. What is the ratio of the Taxes (in constant 2015 US$) of Dominica in 2002 to that in 2005?
Offer a terse response. 0.68. What is the ratio of the Taxes (in constant 2015 US$) of South Africa in 2002 to that in 2005?
Your answer should be very brief. 0.37. What is the ratio of the Taxes (in constant 2015 US$) in Sweden in 2002 to that in 2005?
Offer a terse response. 0.67. What is the ratio of the Taxes (in constant 2015 US$) of Vanuatu in 2002 to that in 2005?
Provide a succinct answer. 0.65. What is the ratio of the Taxes (in constant 2015 US$) in Dominica in 2002 to that in 2006?
Your response must be concise. 0.61. What is the ratio of the Taxes (in constant 2015 US$) of South Africa in 2002 to that in 2006?
Give a very brief answer. 0.34. What is the ratio of the Taxes (in constant 2015 US$) in Sweden in 2002 to that in 2006?
Give a very brief answer. 0.63. What is the ratio of the Taxes (in constant 2015 US$) of Vanuatu in 2002 to that in 2006?
Make the answer very short. 0.59. What is the ratio of the Taxes (in constant 2015 US$) of Dominica in 2002 to that in 2007?
Give a very brief answer. 0.51. What is the ratio of the Taxes (in constant 2015 US$) in South Africa in 2002 to that in 2007?
Your response must be concise. 0.31. What is the ratio of the Taxes (in constant 2015 US$) in Sweden in 2002 to that in 2007?
Offer a terse response. 0.54. What is the ratio of the Taxes (in constant 2015 US$) in Vanuatu in 2002 to that in 2007?
Provide a succinct answer. 0.44. What is the ratio of the Taxes (in constant 2015 US$) in Dominica in 2002 to that in 2008?
Provide a short and direct response. 0.47. What is the ratio of the Taxes (in constant 2015 US$) of South Africa in 2002 to that in 2008?
Your answer should be very brief. 0.36. What is the ratio of the Taxes (in constant 2015 US$) of Sweden in 2002 to that in 2008?
Your answer should be very brief. 0.52. What is the ratio of the Taxes (in constant 2015 US$) of Vanuatu in 2002 to that in 2008?
Provide a succinct answer. 0.37. What is the ratio of the Taxes (in constant 2015 US$) in Dominica in 2002 to that in 2009?
Provide a succinct answer. 0.45. What is the ratio of the Taxes (in constant 2015 US$) of South Africa in 2002 to that in 2009?
Your response must be concise. 0.37. What is the ratio of the Taxes (in constant 2015 US$) in Sweden in 2002 to that in 2009?
Provide a short and direct response. 0.6. What is the ratio of the Taxes (in constant 2015 US$) in Vanuatu in 2002 to that in 2009?
Keep it short and to the point. 0.4. What is the ratio of the Taxes (in constant 2015 US$) of Dominica in 2003 to that in 2004?
Give a very brief answer. 0.84. What is the ratio of the Taxes (in constant 2015 US$) in South Africa in 2003 to that in 2004?
Make the answer very short. 0.69. What is the ratio of the Taxes (in constant 2015 US$) of Sweden in 2003 to that in 2004?
Your answer should be very brief. 0.88. What is the ratio of the Taxes (in constant 2015 US$) in Vanuatu in 2003 to that in 2004?
Your answer should be compact. 0.85. What is the ratio of the Taxes (in constant 2015 US$) in Dominica in 2003 to that in 2005?
Give a very brief answer. 0.78. What is the ratio of the Taxes (in constant 2015 US$) of South Africa in 2003 to that in 2005?
Your answer should be compact. 0.58. What is the ratio of the Taxes (in constant 2015 US$) of Sweden in 2003 to that in 2005?
Keep it short and to the point. 0.84. What is the ratio of the Taxes (in constant 2015 US$) of Vanuatu in 2003 to that in 2005?
Keep it short and to the point. 0.75. What is the ratio of the Taxes (in constant 2015 US$) of Dominica in 2003 to that in 2006?
Give a very brief answer. 0.7. What is the ratio of the Taxes (in constant 2015 US$) in South Africa in 2003 to that in 2006?
Offer a terse response. 0.53. What is the ratio of the Taxes (in constant 2015 US$) of Sweden in 2003 to that in 2006?
Ensure brevity in your answer.  0.79. What is the ratio of the Taxes (in constant 2015 US$) of Vanuatu in 2003 to that in 2006?
Keep it short and to the point. 0.69. What is the ratio of the Taxes (in constant 2015 US$) in Dominica in 2003 to that in 2007?
Offer a very short reply. 0.59. What is the ratio of the Taxes (in constant 2015 US$) in South Africa in 2003 to that in 2007?
Your response must be concise. 0.49. What is the ratio of the Taxes (in constant 2015 US$) of Sweden in 2003 to that in 2007?
Ensure brevity in your answer.  0.68. What is the ratio of the Taxes (in constant 2015 US$) in Vanuatu in 2003 to that in 2007?
Provide a short and direct response. 0.51. What is the ratio of the Taxes (in constant 2015 US$) of Dominica in 2003 to that in 2008?
Offer a very short reply. 0.54. What is the ratio of the Taxes (in constant 2015 US$) in South Africa in 2003 to that in 2008?
Offer a very short reply. 0.55. What is the ratio of the Taxes (in constant 2015 US$) of Sweden in 2003 to that in 2008?
Your response must be concise. 0.65. What is the ratio of the Taxes (in constant 2015 US$) of Vanuatu in 2003 to that in 2008?
Provide a short and direct response. 0.43. What is the ratio of the Taxes (in constant 2015 US$) in Dominica in 2003 to that in 2009?
Your answer should be very brief. 0.51. What is the ratio of the Taxes (in constant 2015 US$) of South Africa in 2003 to that in 2009?
Keep it short and to the point. 0.57. What is the ratio of the Taxes (in constant 2015 US$) in Sweden in 2003 to that in 2009?
Your answer should be very brief. 0.75. What is the ratio of the Taxes (in constant 2015 US$) of Vanuatu in 2003 to that in 2009?
Offer a terse response. 0.46. What is the ratio of the Taxes (in constant 2015 US$) of Dominica in 2004 to that in 2005?
Provide a short and direct response. 0.94. What is the ratio of the Taxes (in constant 2015 US$) of South Africa in 2004 to that in 2005?
Give a very brief answer. 0.84. What is the ratio of the Taxes (in constant 2015 US$) of Sweden in 2004 to that in 2005?
Offer a terse response. 0.96. What is the ratio of the Taxes (in constant 2015 US$) in Vanuatu in 2004 to that in 2005?
Provide a short and direct response. 0.88. What is the ratio of the Taxes (in constant 2015 US$) of Dominica in 2004 to that in 2006?
Offer a terse response. 0.83. What is the ratio of the Taxes (in constant 2015 US$) of South Africa in 2004 to that in 2006?
Offer a terse response. 0.77. What is the ratio of the Taxes (in constant 2015 US$) in Sweden in 2004 to that in 2006?
Your answer should be compact. 0.9. What is the ratio of the Taxes (in constant 2015 US$) of Vanuatu in 2004 to that in 2006?
Offer a terse response. 0.81. What is the ratio of the Taxes (in constant 2015 US$) in Dominica in 2004 to that in 2007?
Your answer should be very brief. 0.7. What is the ratio of the Taxes (in constant 2015 US$) of South Africa in 2004 to that in 2007?
Make the answer very short. 0.7. What is the ratio of the Taxes (in constant 2015 US$) of Sweden in 2004 to that in 2007?
Ensure brevity in your answer.  0.78. What is the ratio of the Taxes (in constant 2015 US$) in Vanuatu in 2004 to that in 2007?
Offer a very short reply. 0.6. What is the ratio of the Taxes (in constant 2015 US$) of Dominica in 2004 to that in 2008?
Your answer should be very brief. 0.64. What is the ratio of the Taxes (in constant 2015 US$) of South Africa in 2004 to that in 2008?
Offer a terse response. 0.8. What is the ratio of the Taxes (in constant 2015 US$) of Sweden in 2004 to that in 2008?
Your answer should be compact. 0.74. What is the ratio of the Taxes (in constant 2015 US$) of Vanuatu in 2004 to that in 2008?
Ensure brevity in your answer.  0.5. What is the ratio of the Taxes (in constant 2015 US$) of Dominica in 2004 to that in 2009?
Your response must be concise. 0.61. What is the ratio of the Taxes (in constant 2015 US$) of South Africa in 2004 to that in 2009?
Provide a succinct answer. 0.82. What is the ratio of the Taxes (in constant 2015 US$) in Sweden in 2004 to that in 2009?
Provide a short and direct response. 0.85. What is the ratio of the Taxes (in constant 2015 US$) of Vanuatu in 2004 to that in 2009?
Your answer should be very brief. 0.54. What is the ratio of the Taxes (in constant 2015 US$) of Dominica in 2005 to that in 2006?
Give a very brief answer. 0.89. What is the ratio of the Taxes (in constant 2015 US$) in South Africa in 2005 to that in 2006?
Give a very brief answer. 0.92. What is the ratio of the Taxes (in constant 2015 US$) in Sweden in 2005 to that in 2006?
Make the answer very short. 0.94. What is the ratio of the Taxes (in constant 2015 US$) in Vanuatu in 2005 to that in 2006?
Your answer should be very brief. 0.91. What is the ratio of the Taxes (in constant 2015 US$) in Dominica in 2005 to that in 2007?
Your response must be concise. 0.75. What is the ratio of the Taxes (in constant 2015 US$) in South Africa in 2005 to that in 2007?
Keep it short and to the point. 0.84. What is the ratio of the Taxes (in constant 2015 US$) of Sweden in 2005 to that in 2007?
Your response must be concise. 0.81. What is the ratio of the Taxes (in constant 2015 US$) of Vanuatu in 2005 to that in 2007?
Your response must be concise. 0.68. What is the ratio of the Taxes (in constant 2015 US$) in Dominica in 2005 to that in 2008?
Give a very brief answer. 0.69. What is the ratio of the Taxes (in constant 2015 US$) of South Africa in 2005 to that in 2008?
Offer a very short reply. 0.95. What is the ratio of the Taxes (in constant 2015 US$) of Sweden in 2005 to that in 2008?
Make the answer very short. 0.78. What is the ratio of the Taxes (in constant 2015 US$) of Vanuatu in 2005 to that in 2008?
Your answer should be compact. 0.57. What is the ratio of the Taxes (in constant 2015 US$) in Dominica in 2005 to that in 2009?
Your answer should be compact. 0.65. What is the ratio of the Taxes (in constant 2015 US$) of South Africa in 2005 to that in 2009?
Your answer should be very brief. 0.98. What is the ratio of the Taxes (in constant 2015 US$) in Sweden in 2005 to that in 2009?
Ensure brevity in your answer.  0.89. What is the ratio of the Taxes (in constant 2015 US$) in Vanuatu in 2005 to that in 2009?
Give a very brief answer. 0.62. What is the ratio of the Taxes (in constant 2015 US$) of Dominica in 2006 to that in 2007?
Your answer should be compact. 0.85. What is the ratio of the Taxes (in constant 2015 US$) of South Africa in 2006 to that in 2007?
Provide a succinct answer. 0.91. What is the ratio of the Taxes (in constant 2015 US$) in Sweden in 2006 to that in 2007?
Make the answer very short. 0.87. What is the ratio of the Taxes (in constant 2015 US$) in Vanuatu in 2006 to that in 2007?
Offer a terse response. 0.75. What is the ratio of the Taxes (in constant 2015 US$) of Dominica in 2006 to that in 2008?
Offer a terse response. 0.77. What is the ratio of the Taxes (in constant 2015 US$) of South Africa in 2006 to that in 2008?
Provide a succinct answer. 1.04. What is the ratio of the Taxes (in constant 2015 US$) in Sweden in 2006 to that in 2008?
Your answer should be very brief. 0.83. What is the ratio of the Taxes (in constant 2015 US$) in Vanuatu in 2006 to that in 2008?
Offer a terse response. 0.63. What is the ratio of the Taxes (in constant 2015 US$) in Dominica in 2006 to that in 2009?
Ensure brevity in your answer.  0.73. What is the ratio of the Taxes (in constant 2015 US$) of South Africa in 2006 to that in 2009?
Offer a terse response. 1.07. What is the ratio of the Taxes (in constant 2015 US$) in Sweden in 2006 to that in 2009?
Your answer should be compact. 0.95. What is the ratio of the Taxes (in constant 2015 US$) in Vanuatu in 2006 to that in 2009?
Keep it short and to the point. 0.68. What is the ratio of the Taxes (in constant 2015 US$) in Dominica in 2007 to that in 2008?
Provide a short and direct response. 0.91. What is the ratio of the Taxes (in constant 2015 US$) in South Africa in 2007 to that in 2008?
Ensure brevity in your answer.  1.14. What is the ratio of the Taxes (in constant 2015 US$) of Sweden in 2007 to that in 2008?
Your answer should be very brief. 0.96. What is the ratio of the Taxes (in constant 2015 US$) of Vanuatu in 2007 to that in 2008?
Offer a terse response. 0.84. What is the ratio of the Taxes (in constant 2015 US$) in Dominica in 2007 to that in 2009?
Keep it short and to the point. 0.87. What is the ratio of the Taxes (in constant 2015 US$) of South Africa in 2007 to that in 2009?
Your answer should be very brief. 1.17. What is the ratio of the Taxes (in constant 2015 US$) of Vanuatu in 2007 to that in 2009?
Offer a very short reply. 0.91. What is the ratio of the Taxes (in constant 2015 US$) in Dominica in 2008 to that in 2009?
Offer a terse response. 0.95. What is the ratio of the Taxes (in constant 2015 US$) of South Africa in 2008 to that in 2009?
Provide a succinct answer. 1.03. What is the ratio of the Taxes (in constant 2015 US$) of Sweden in 2008 to that in 2009?
Give a very brief answer. 1.15. What is the ratio of the Taxes (in constant 2015 US$) in Vanuatu in 2008 to that in 2009?
Provide a short and direct response. 1.08. What is the difference between the highest and the second highest Taxes (in constant 2015 US$) of Dominica?
Give a very brief answer. 4.10e+06. What is the difference between the highest and the second highest Taxes (in constant 2015 US$) of South Africa?
Provide a succinct answer. 2.79e+09. What is the difference between the highest and the second highest Taxes (in constant 2015 US$) of Sweden?
Ensure brevity in your answer.  2.43e+09. What is the difference between the highest and the second highest Taxes (in constant 2015 US$) of Vanuatu?
Make the answer very short. 6.08e+06. What is the difference between the highest and the lowest Taxes (in constant 2015 US$) in Dominica?
Make the answer very short. 4.77e+07. What is the difference between the highest and the lowest Taxes (in constant 2015 US$) of South Africa?
Give a very brief answer. 2.19e+1. What is the difference between the highest and the lowest Taxes (in constant 2015 US$) of Sweden?
Keep it short and to the point. 2.87e+1. What is the difference between the highest and the lowest Taxes (in constant 2015 US$) of Vanuatu?
Your response must be concise. 5.22e+07. 